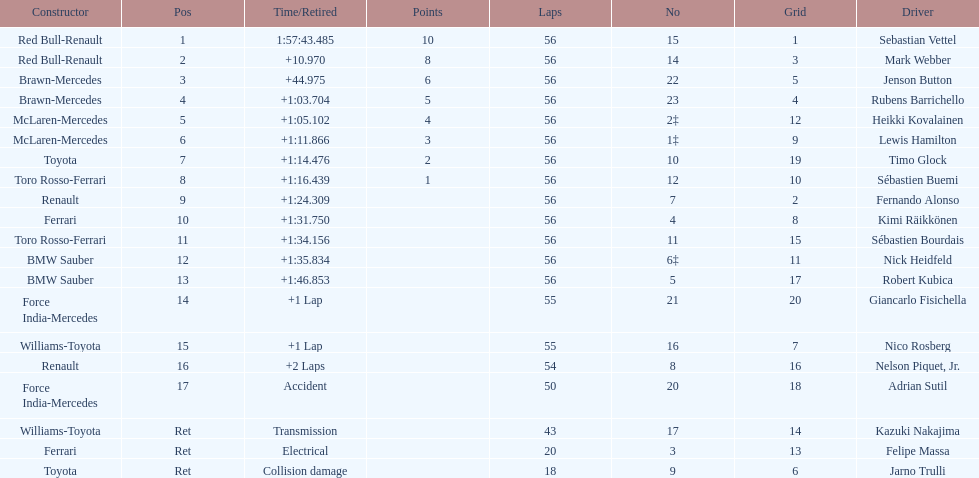What was jenson button's time? +44.975. 